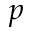Convert formula to latex. <formula><loc_0><loc_0><loc_500><loc_500>p</formula> 